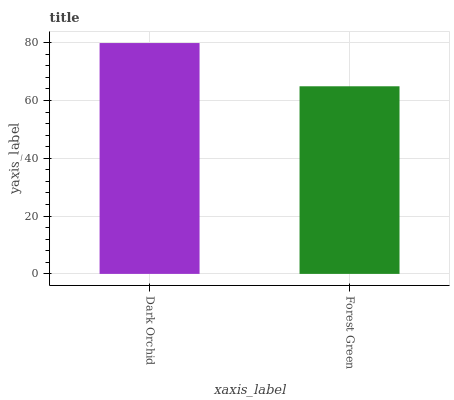Is Forest Green the maximum?
Answer yes or no. No. Is Dark Orchid greater than Forest Green?
Answer yes or no. Yes. Is Forest Green less than Dark Orchid?
Answer yes or no. Yes. Is Forest Green greater than Dark Orchid?
Answer yes or no. No. Is Dark Orchid less than Forest Green?
Answer yes or no. No. Is Dark Orchid the high median?
Answer yes or no. Yes. Is Forest Green the low median?
Answer yes or no. Yes. Is Forest Green the high median?
Answer yes or no. No. Is Dark Orchid the low median?
Answer yes or no. No. 